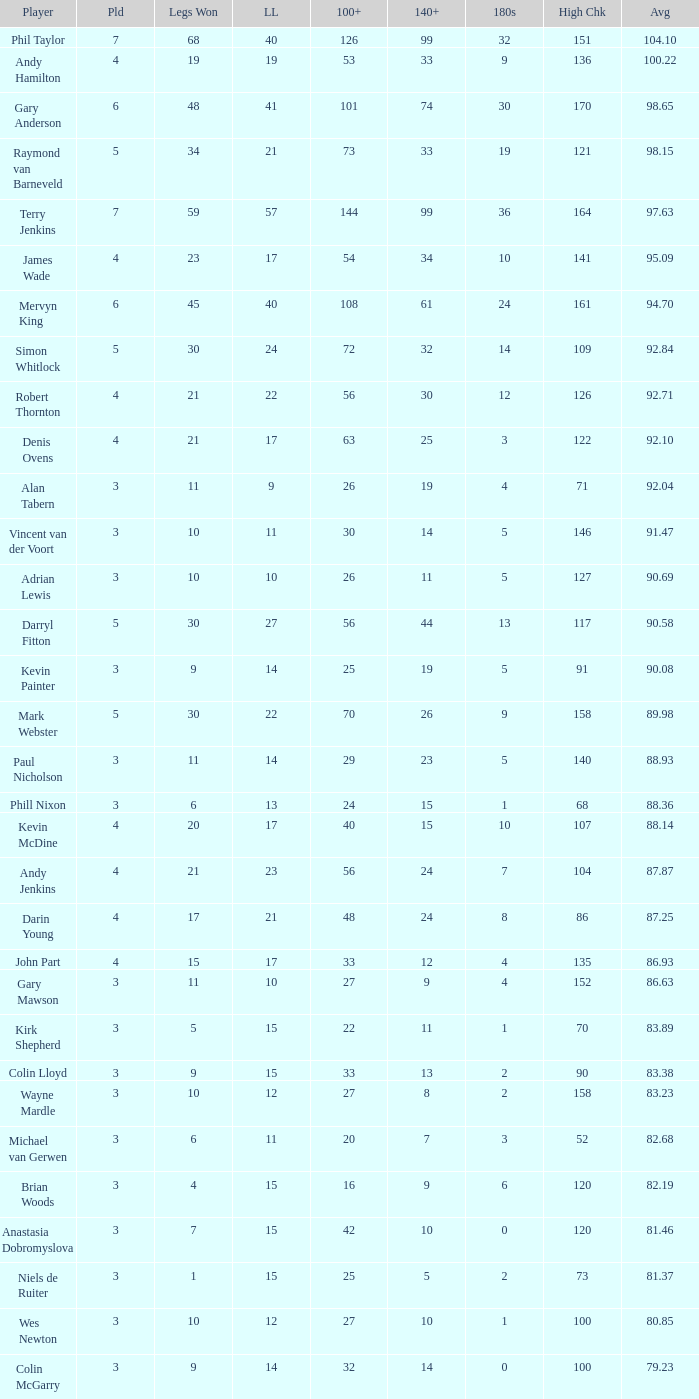What is the played number when the high checkout is 135? 4.0. 